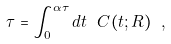<formula> <loc_0><loc_0><loc_500><loc_500>\tau = \int _ { 0 } ^ { \alpha \tau } d t \ C ( t ; R ) \ ,</formula> 